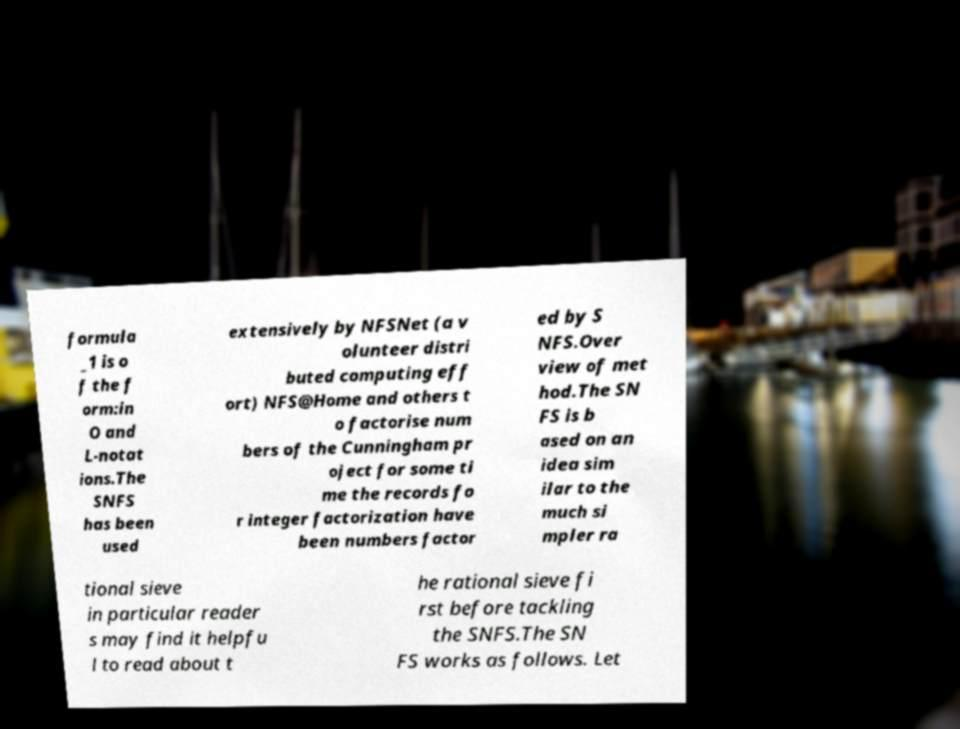For documentation purposes, I need the text within this image transcribed. Could you provide that? formula _1 is o f the f orm:in O and L-notat ions.The SNFS has been used extensively by NFSNet (a v olunteer distri buted computing eff ort) NFS@Home and others t o factorise num bers of the Cunningham pr oject for some ti me the records fo r integer factorization have been numbers factor ed by S NFS.Over view of met hod.The SN FS is b ased on an idea sim ilar to the much si mpler ra tional sieve in particular reader s may find it helpfu l to read about t he rational sieve fi rst before tackling the SNFS.The SN FS works as follows. Let 